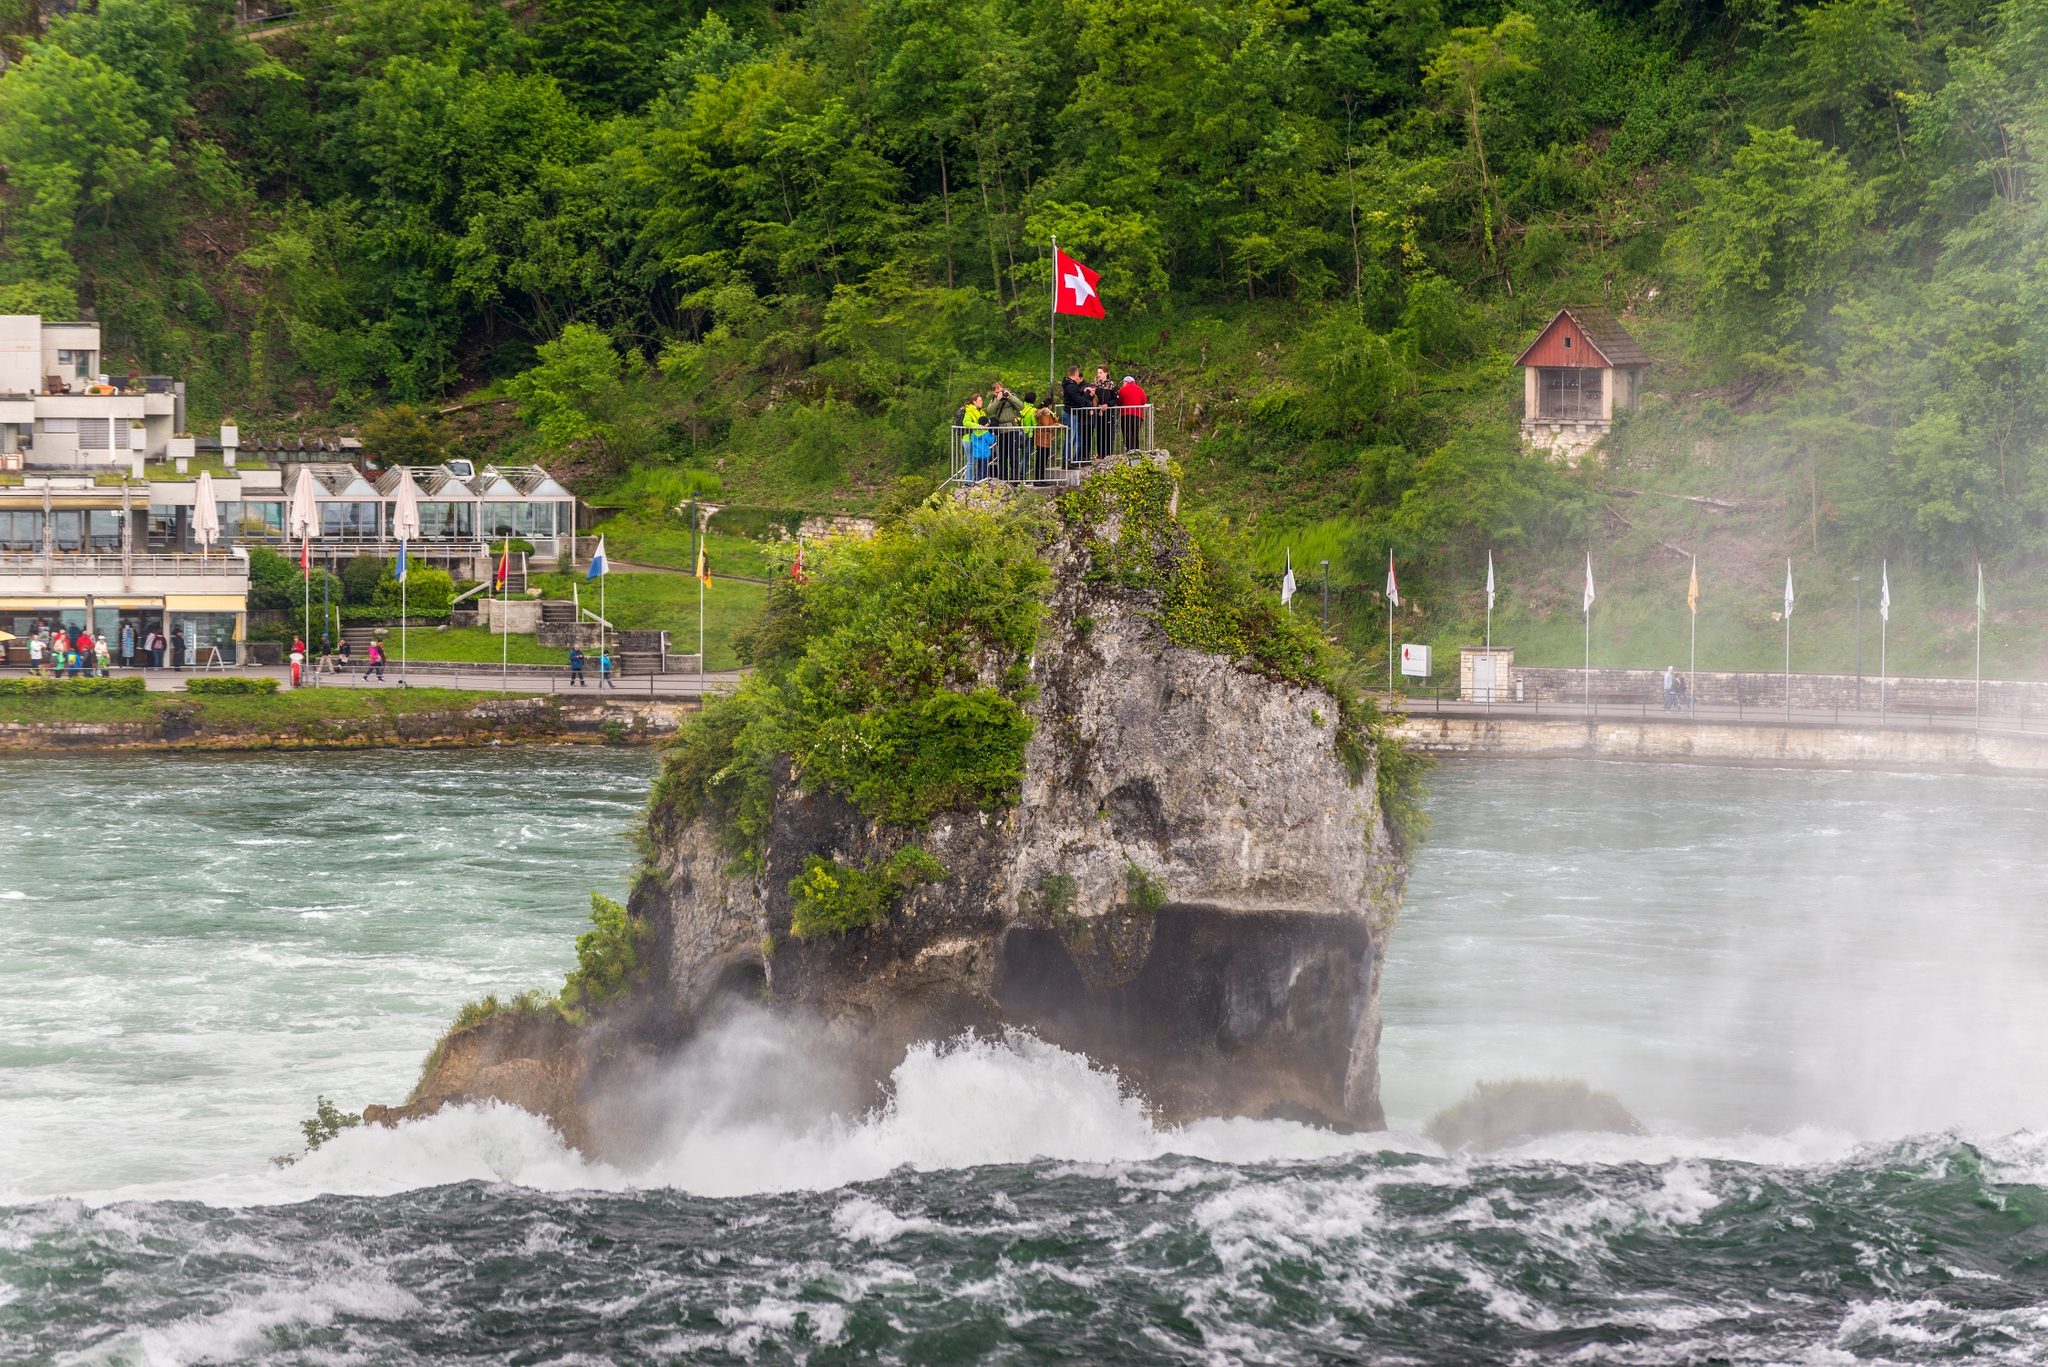What do you see happening in this image? The image captures the majestic Rhine Falls, one of the world's most renowned waterfalls, located in Switzerland. The waterfall's powerful torrents of light blue water create a misty backdrop, adding to the scene's ethereal beauty. Dominating the center of the river is a rock formation, blanketed in lush greenery, proudly bearing a Swiss flag at its peak. Nestled on the right side of this formation is a quaint wooden hut, adding a touch of rustic charm to the otherwise wild landscape. The image is captured from a slightly elevated perspective, offering a panoramic view of this natural spectacle. The identifier "sa_14524" might be a reference to the specific viewpoint or photo series this image belongs to. 